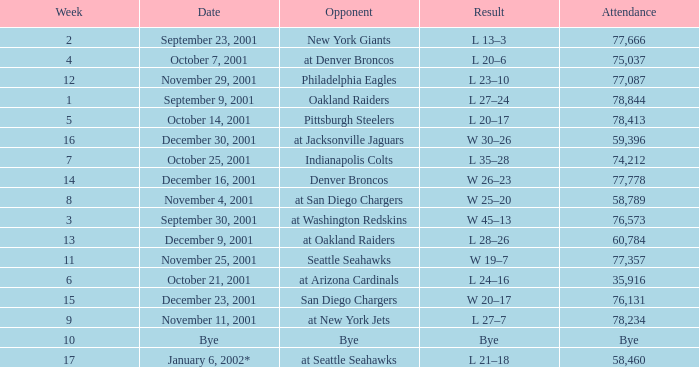How many attended the game on December 16, 2001? 77778.0. 